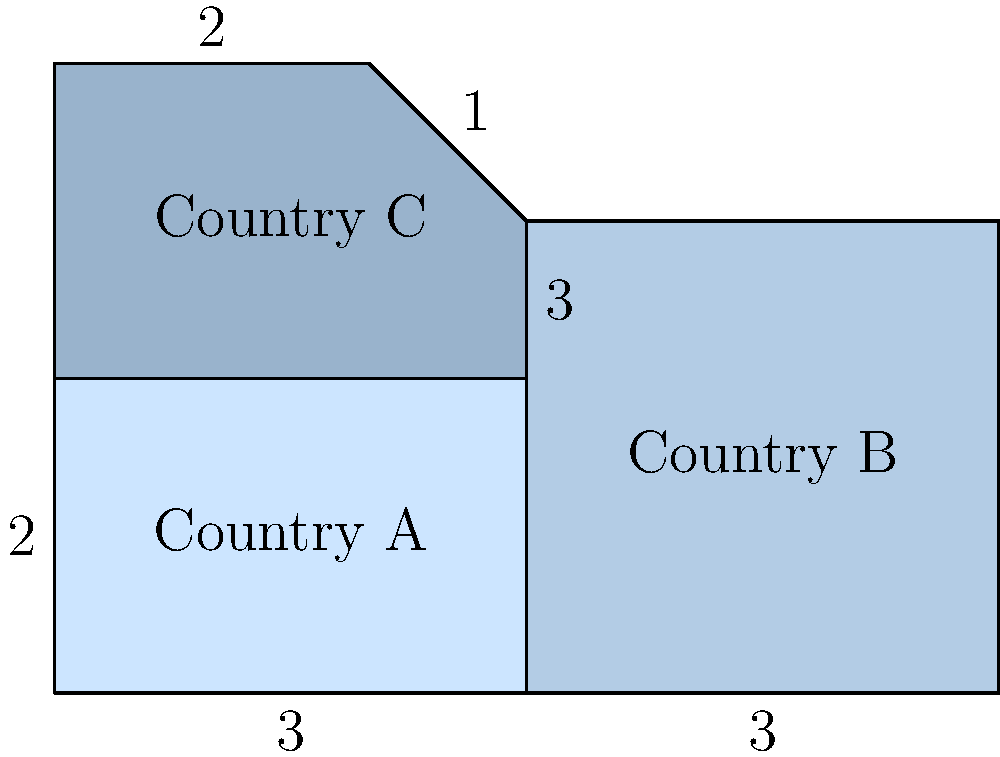The irregular shapes in the diagram represent the progress of three countries (A, B, and C) in women's rights. The area of each shape corresponds to the overall improvement in women's rights policies. If the total area of all three shapes is 21 square units, what is the area of the shape representing Country C's progress? To solve this problem, we need to follow these steps:

1. Calculate the areas of Countries A and B:
   - Country A: Rectangle with width 3 and height 2
     Area of A = $3 \times 2 = 6$ square units
   - Country B: Rectangle with width 3 and height 3
     Area of B = $3 \times 3 = 9$ square units

2. Calculate the total area of all countries:
   Total area = 21 square units (given in the question)

3. Calculate the area of Country C:
   Area of C = Total area - (Area of A + Area of B)
   Area of C = $21 - (6 + 9) = 21 - 15 = 6$ square units

4. Verify the result:
   The shape for Country C is a trapezoid with bases 3 and 2, and height 2.
   Area of a trapezoid = $\frac{1}{2}(b_1 + b_2)h$
   Area of C = $\frac{1}{2}(3 + 2) \times 2 = \frac{1}{2} \times 5 \times 2 = 5$ square units

   The slight discrepancy (5 vs 6) is due to the irregular shape and approximation in the diagram.

Therefore, the area representing Country C's progress in women's rights is approximately 6 square units.
Answer: 6 square units 